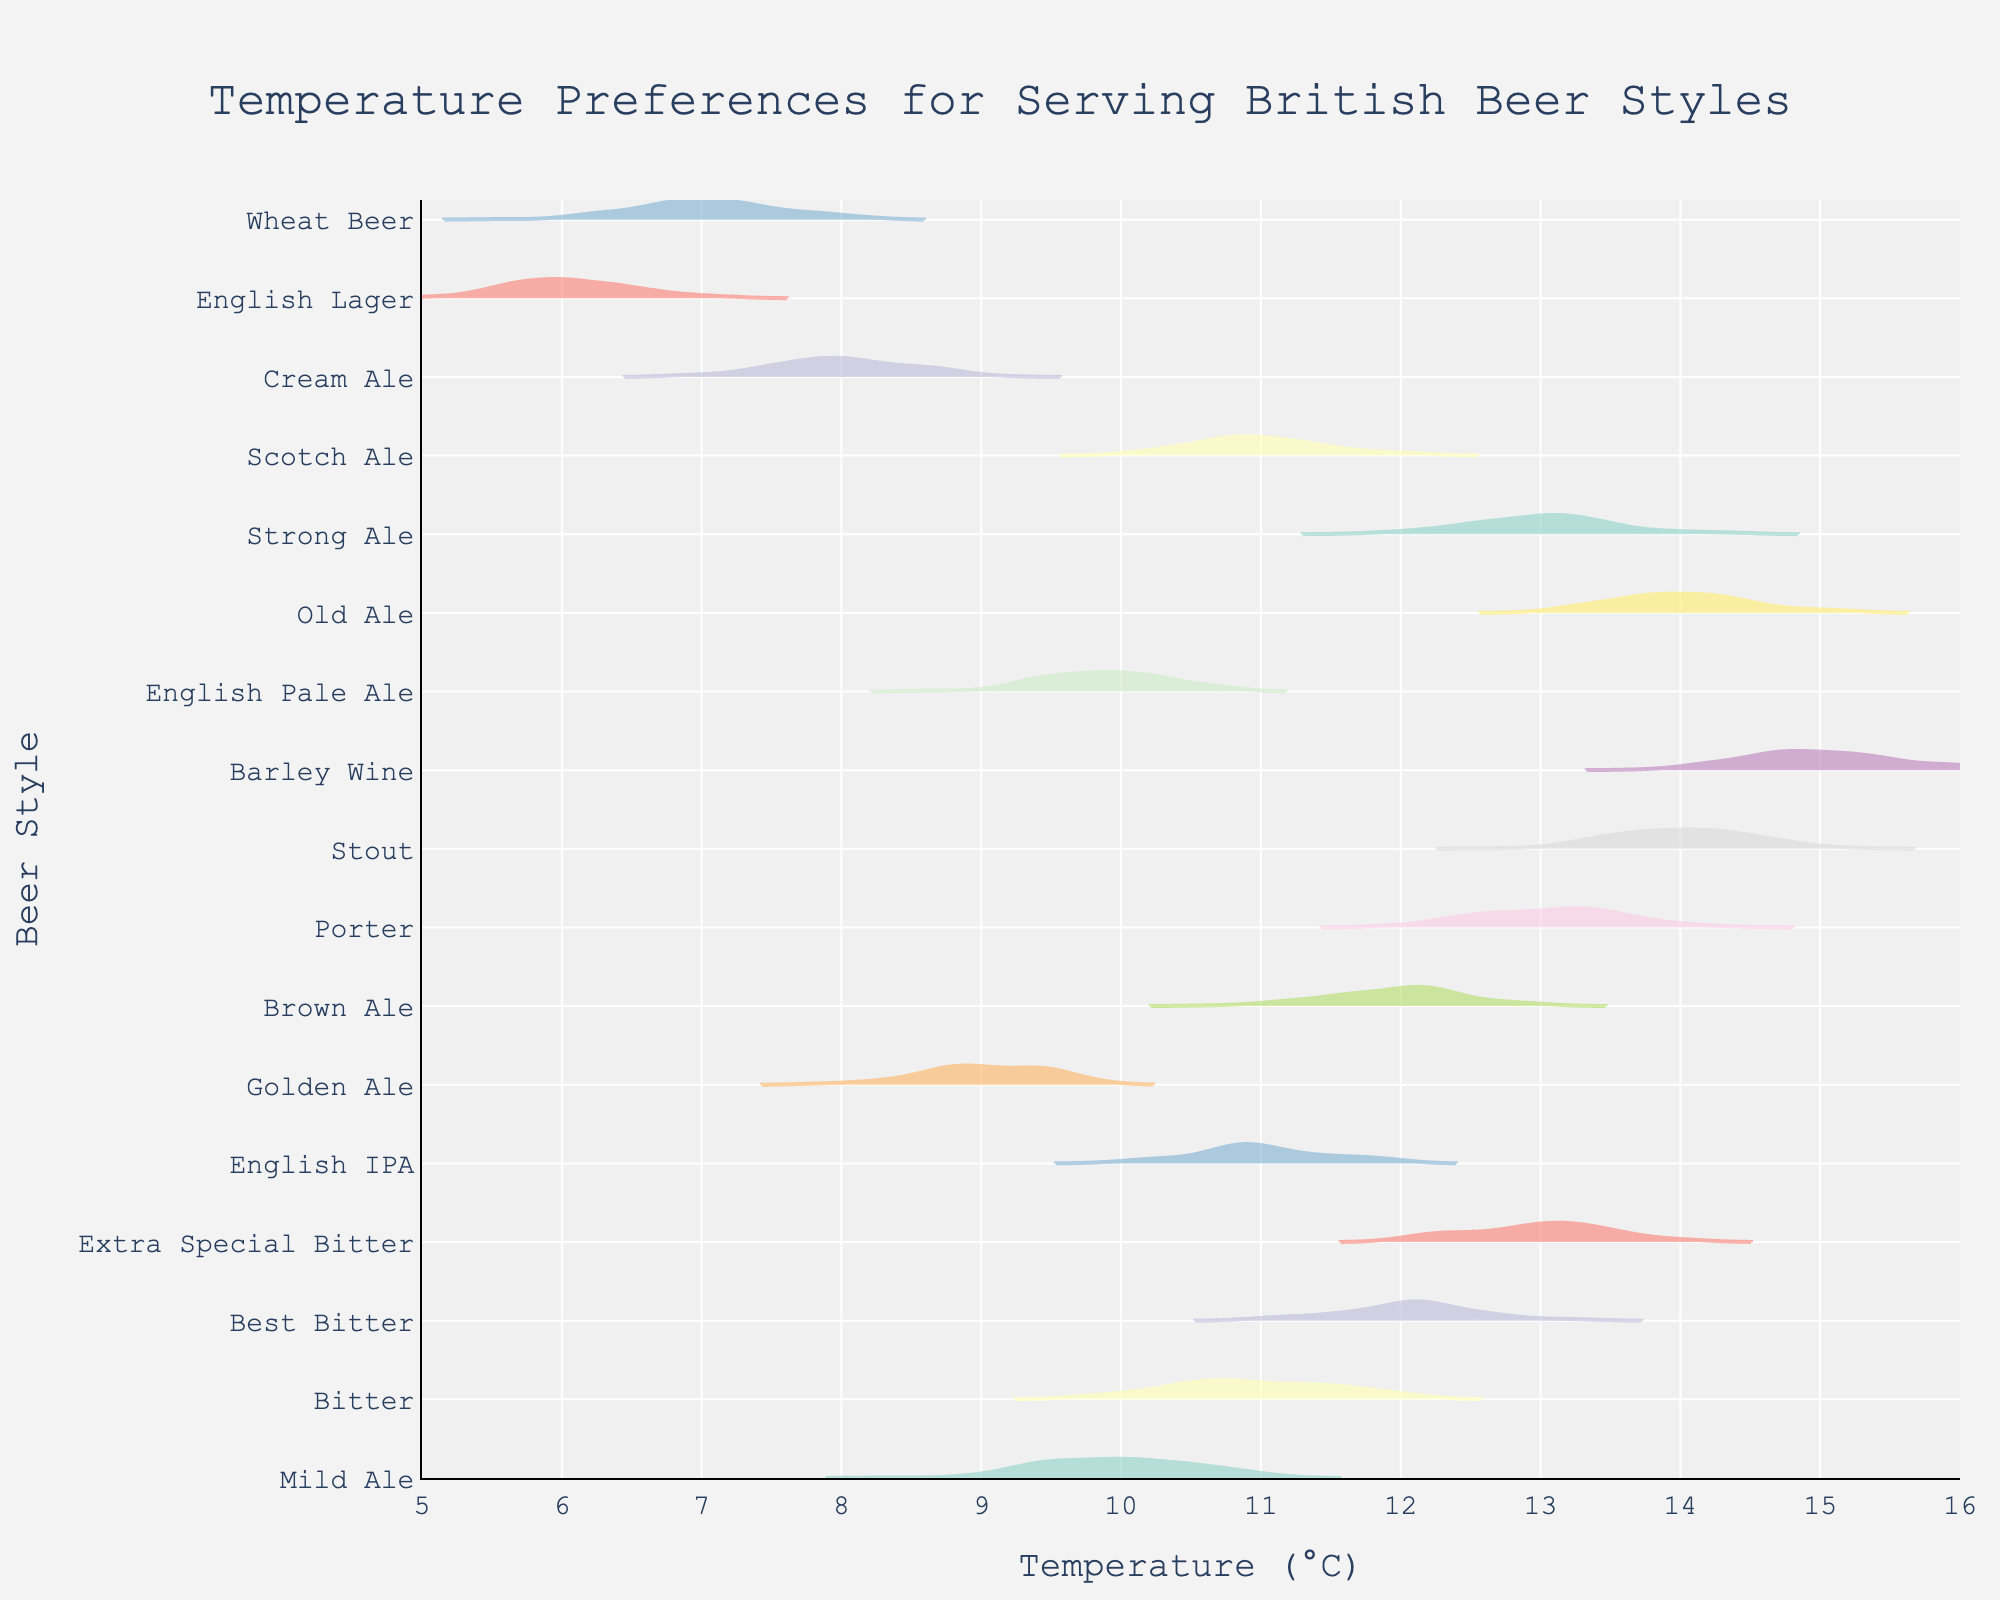What is the title of the plot? The title is usually placed at the top of the plot. By examining the top part of the figure, we can see that it reads "Temperature Preferences for Serving British Beer Styles".
Answer: Temperature Preferences for Serving British Beer Styles What is the range of the x-axis in the plot? The x-axis typically represents the temperature in degrees Celsius. By looking at the figures on the x-axis, we can see that the range is from 5°C to 16°C.
Answer: 5°C to 16°C Which beer style is served at the lowest temperature according to the plot? By reviewing the different beer styles and the corresponding density plots, we can see that 'English Lager' has the density centered around 6°C, which is the lowest in the plot.
Answer: English Lager What is the approximate temperature range for serving 'Stout'? By locating 'Stout' on the y-axis and observing the x-values where its density is spread, we can see it roughly spans from 13.5°C to 14.5°C.
Answer: 13.5°C to 14.5°C Which beer style has the highest serving temperature? By inspecting the density plot with the highest x-value, we can see that 'Barley Wine' has a temperature centered around 15°C, which is the highest in the plot.
Answer: Barley Wine How many beer styles are noted in this plot? Examining the y-axis, we can count the number of unique beer styles. There are 17 data points, each representing a different beer style.
Answer: 17 What is the median serving temperature of all the beer styles shown? To find the median, we list all temperatures: 6, 7, 8, 9, 10, 10, 11, 11, 11, 12, 12, 13, 13, 13, 14, 14, 15. The median is the middle value in this ordered list, which is 12 (the 9th value out of 17).
Answer: 12 Is the serving temperature for 'English IPA' greater than 'Golden Ale'? Observing the density plots for both beer styles, 'English IPA' is around 11°C, while 'Golden Ale' is around 9°C. Therefore, 'English IPA' has a higher serving temperature.
Answer: Yes Do 'Porter' and 'Old Ale' have the same preferred serving temperature? Looking at the density plots for both 'Porter' and 'Old Ale', we see that they are both centered around 14°C.
Answer: Yes Compare the serving temperatures for 'Mild Ale' and 'Bitter'. Which one is higher? By observing the density plots for both 'Mild Ale' and 'Bitter', 'Bitter' is at around 11°C, while 'Mild Ale' is around 10°C. Hence, 'Bitter' has a higher serving temperature.
Answer: Bitter 